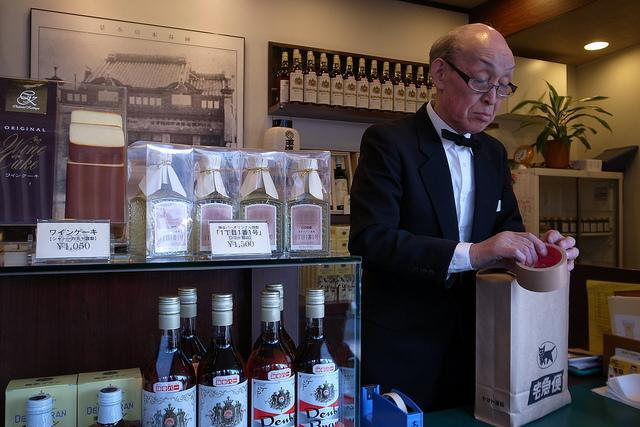What sort of beverages are sold here? Please explain your reasoning. alcoholic. There are bottles of alcohol on the shelf. 